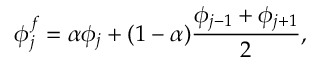Convert formula to latex. <formula><loc_0><loc_0><loc_500><loc_500>\phi _ { j } ^ { f } = \alpha \phi _ { j } + ( 1 - \alpha ) \frac { \phi _ { j - 1 } + \phi _ { j + 1 } } { 2 } ,</formula> 